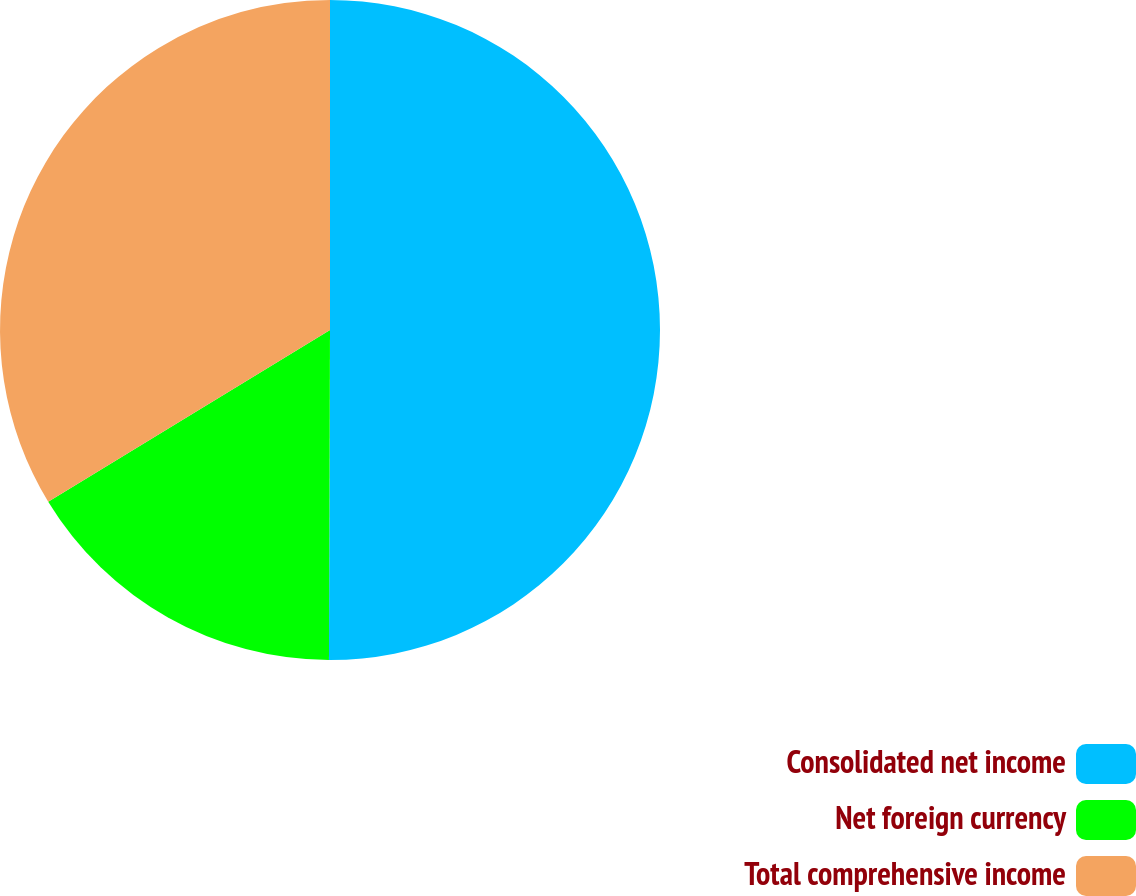Convert chart to OTSL. <chart><loc_0><loc_0><loc_500><loc_500><pie_chart><fcel>Consolidated net income<fcel>Net foreign currency<fcel>Total comprehensive income<nl><fcel>50.05%<fcel>16.24%<fcel>33.71%<nl></chart> 